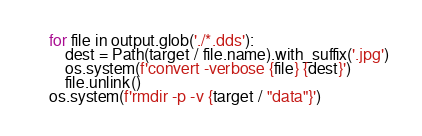<code> <loc_0><loc_0><loc_500><loc_500><_Python_>    for file in output.glob('./*.dds'):
        dest = Path(target / file.name).with_suffix('.jpg')
        os.system(f'convert -verbose {file} {dest}')
        file.unlink()
    os.system(f'rmdir -p -v {target / "data"}')
</code> 